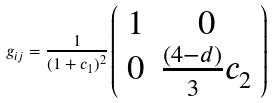<formula> <loc_0><loc_0><loc_500><loc_500>g _ { i j } = \frac { 1 } { ( 1 + c _ { 1 } ) ^ { 2 } } \left ( \begin{array} { c c } 1 & 0 \\ 0 & \frac { ( 4 - d ) } { 3 } c _ { 2 } \end{array} \right )</formula> 